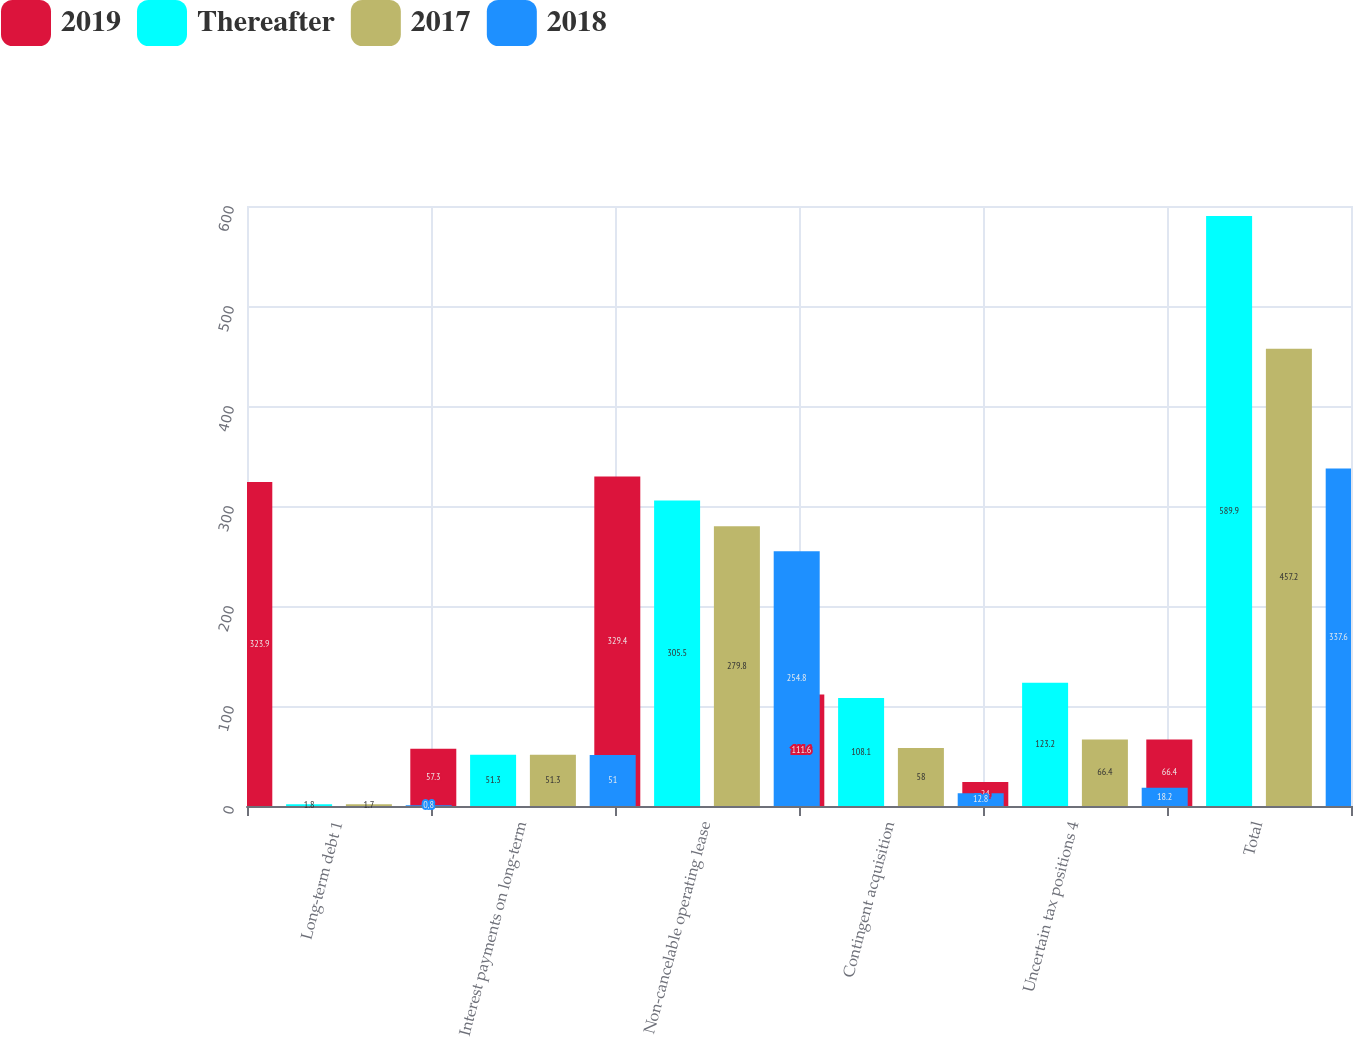Convert chart to OTSL. <chart><loc_0><loc_0><loc_500><loc_500><stacked_bar_chart><ecel><fcel>Long-term debt 1<fcel>Interest payments on long-term<fcel>Non-cancelable operating lease<fcel>Contingent acquisition<fcel>Uncertain tax positions 4<fcel>Total<nl><fcel>2019<fcel>323.9<fcel>57.3<fcel>329.4<fcel>111.6<fcel>24<fcel>66.4<nl><fcel>Thereafter<fcel>1.8<fcel>51.3<fcel>305.5<fcel>108.1<fcel>123.2<fcel>589.9<nl><fcel>2017<fcel>1.7<fcel>51.3<fcel>279.8<fcel>58<fcel>66.4<fcel>457.2<nl><fcel>2018<fcel>0.8<fcel>51<fcel>254.8<fcel>12.8<fcel>18.2<fcel>337.6<nl></chart> 